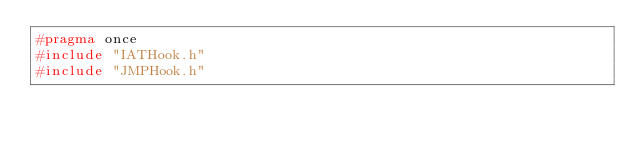<code> <loc_0><loc_0><loc_500><loc_500><_C_>#pragma once
#include "IATHook.h"
#include "JMPHook.h"
</code> 